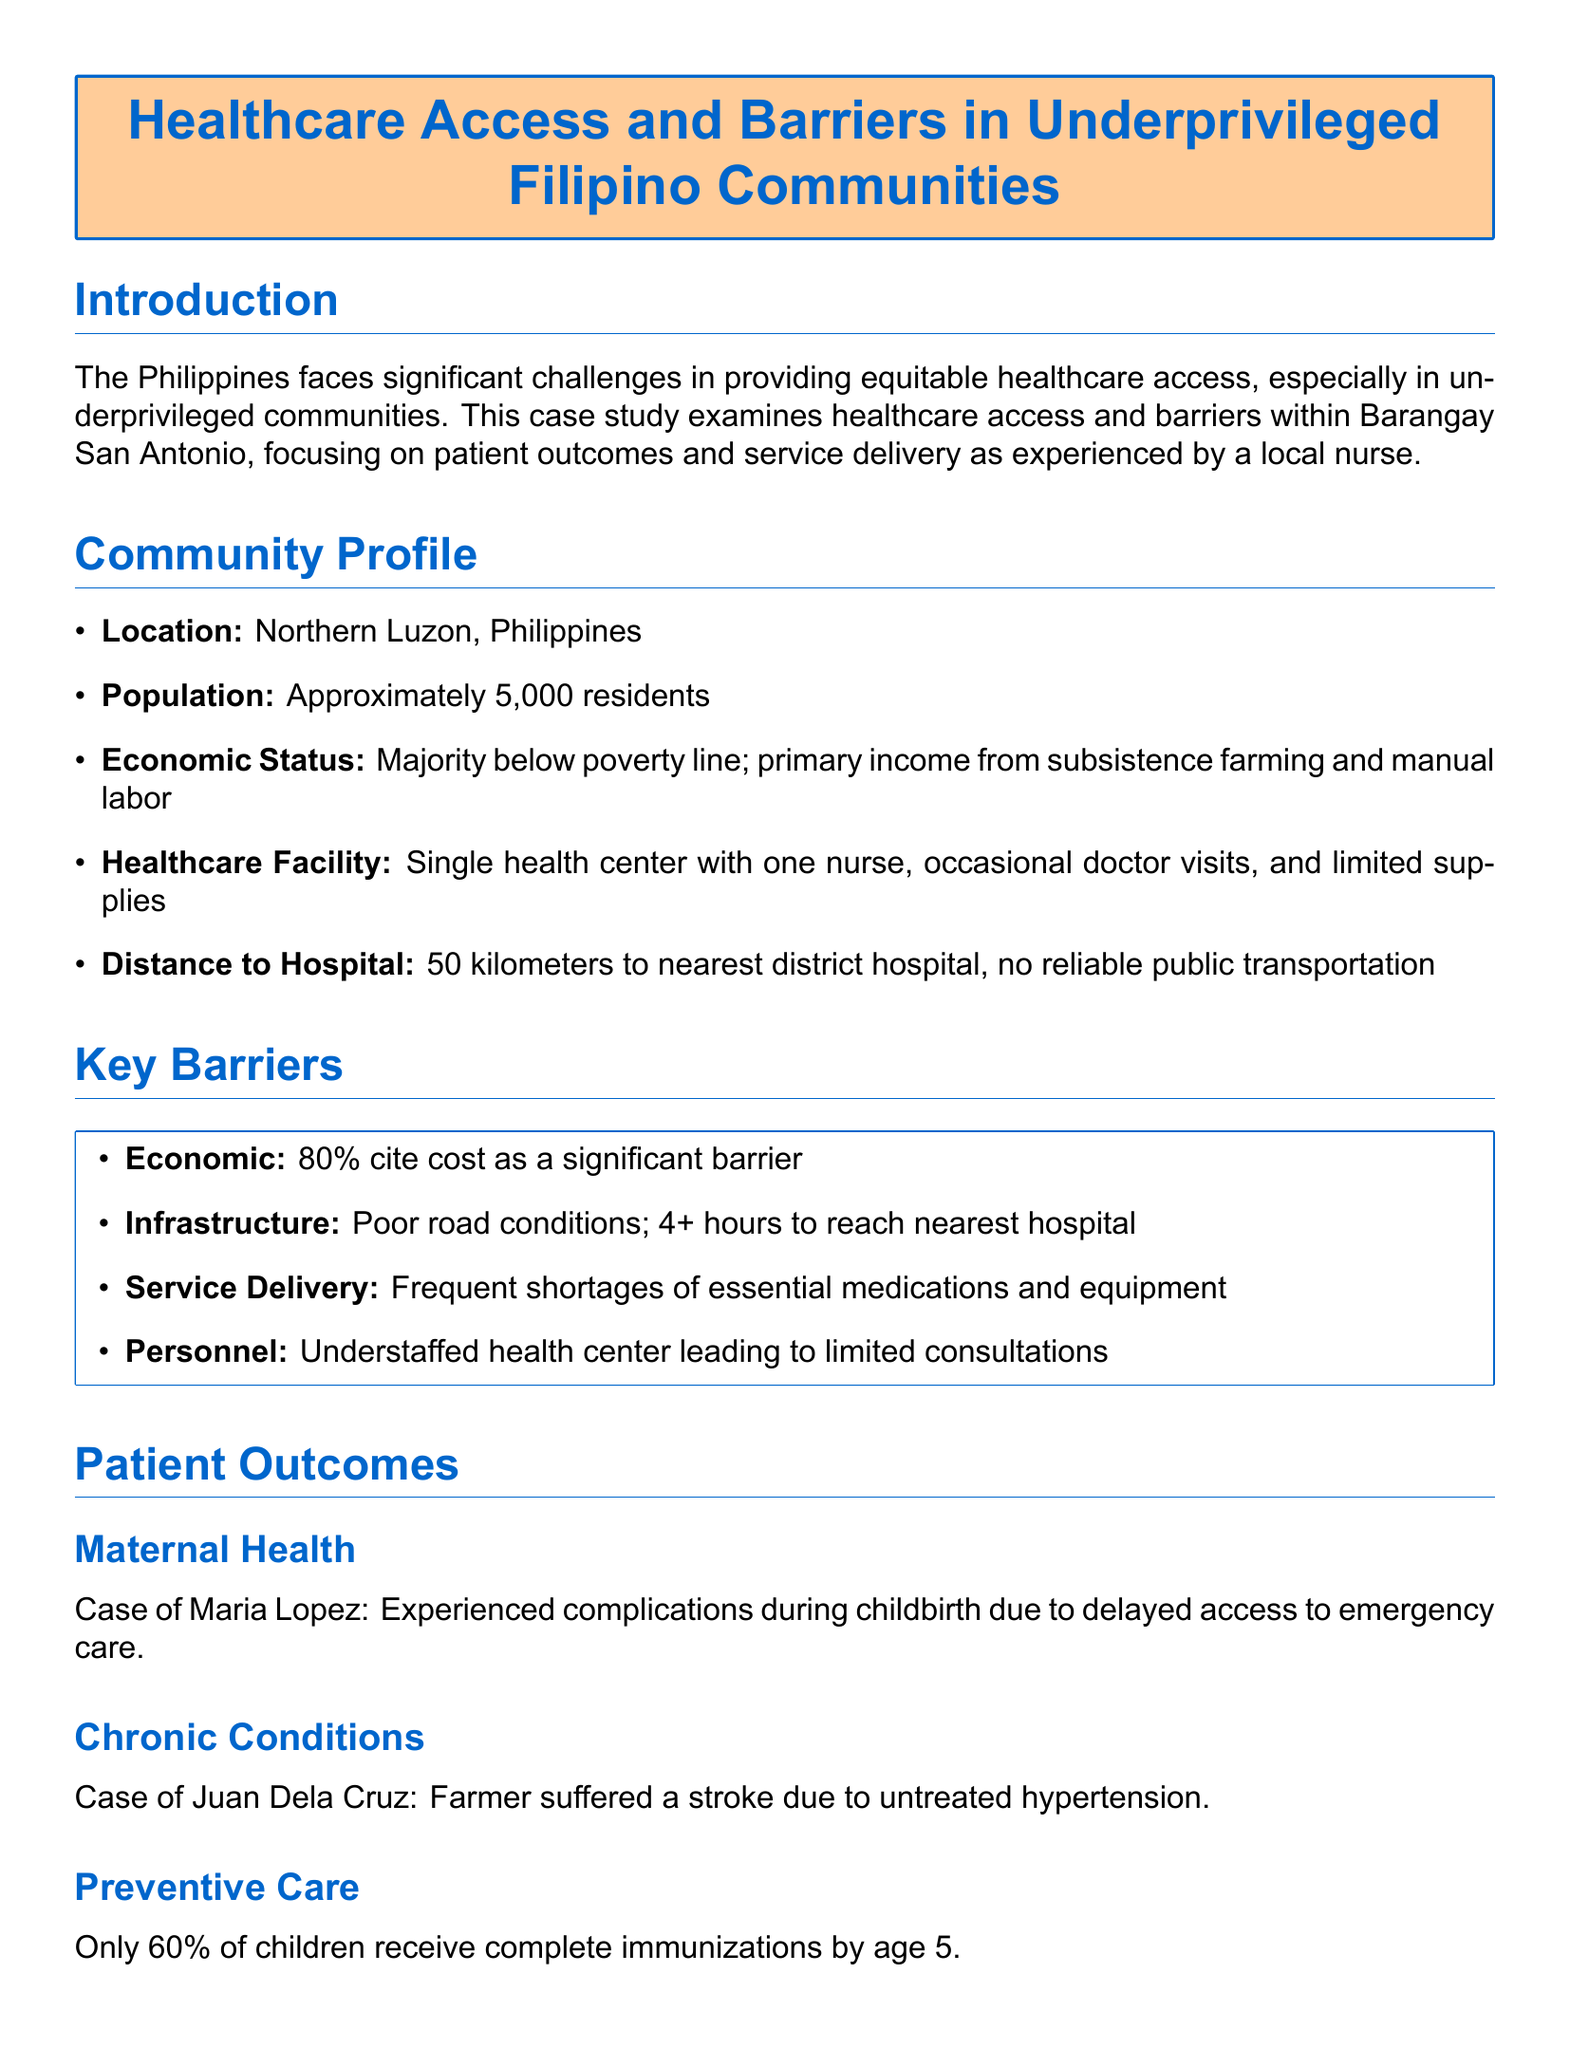what is the location of the community studied? The document states that the community is located in Northern Luzon, Philippines.
Answer: Northern Luzon what is the population of Barangay San Antonio? The document indicates that the approximate population of Barangay San Antonio is 5,000 residents.
Answer: 5,000 residents what is the distance to the nearest hospital? The case study notes that the distance to the nearest district hospital is 50 kilometers.
Answer: 50 kilometers what percentage of the population cites cost as a barrier to healthcare? The document says that 80% of respondents cite cost as a significant barrier.
Answer: 80% what was the complication faced by Maria Lopez? The case study mentions that Maria Lopez experienced complications during childbirth.
Answer: complications during childbirth how many children receive complete immunizations by age 5? The document states that only 60% of children receive complete immunizations by age 5.
Answer: 60% what justification is given for underfunded health centers? The document explains that rural health centers are understaffed, leading to limited consultations.
Answer: understaffed health center what is one recommendation made in the case study? The document suggests improving road conditions and reliable transportation as one of the recommendations.
Answer: Invest in road improvements 